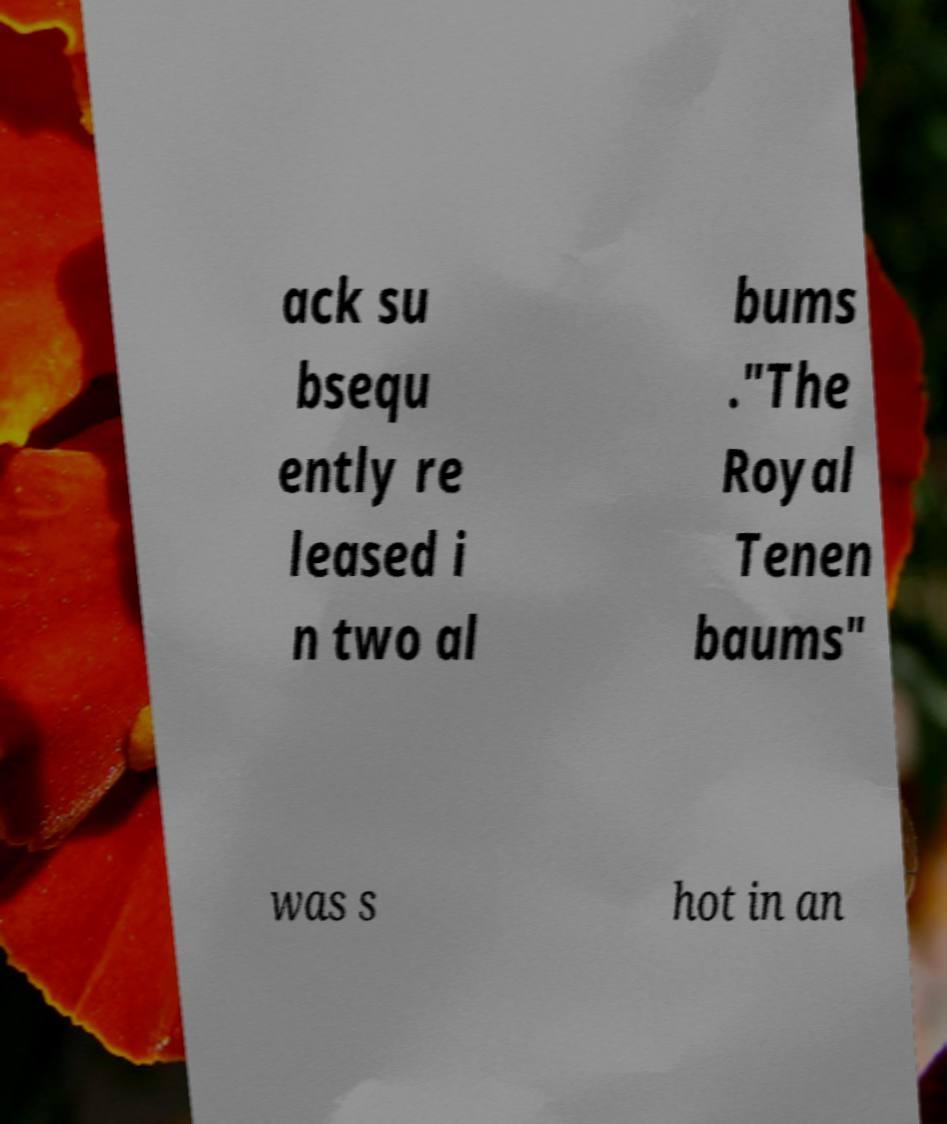There's text embedded in this image that I need extracted. Can you transcribe it verbatim? ack su bsequ ently re leased i n two al bums ."The Royal Tenen baums" was s hot in an 